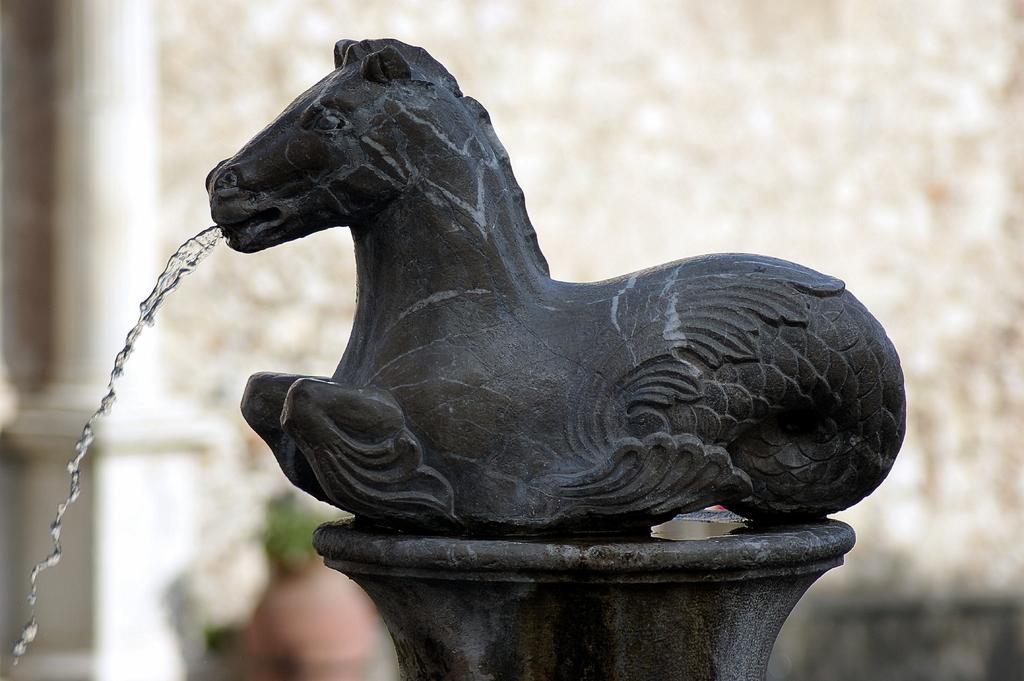Please provide a concise description of this image. In this image there is a statue of an animal from which water is falling down from its mouth. 